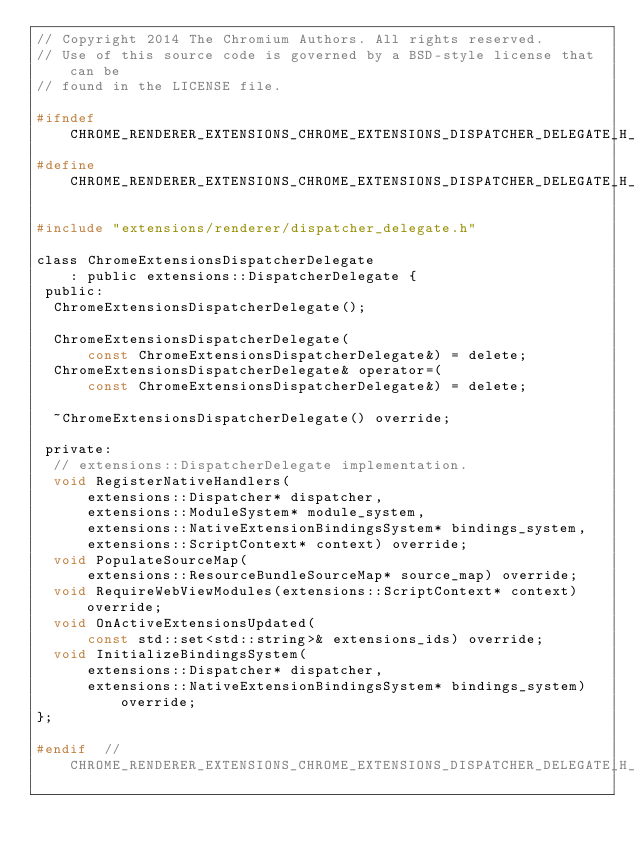Convert code to text. <code><loc_0><loc_0><loc_500><loc_500><_C_>// Copyright 2014 The Chromium Authors. All rights reserved.
// Use of this source code is governed by a BSD-style license that can be
// found in the LICENSE file.

#ifndef CHROME_RENDERER_EXTENSIONS_CHROME_EXTENSIONS_DISPATCHER_DELEGATE_H_
#define CHROME_RENDERER_EXTENSIONS_CHROME_EXTENSIONS_DISPATCHER_DELEGATE_H_

#include "extensions/renderer/dispatcher_delegate.h"

class ChromeExtensionsDispatcherDelegate
    : public extensions::DispatcherDelegate {
 public:
  ChromeExtensionsDispatcherDelegate();

  ChromeExtensionsDispatcherDelegate(
      const ChromeExtensionsDispatcherDelegate&) = delete;
  ChromeExtensionsDispatcherDelegate& operator=(
      const ChromeExtensionsDispatcherDelegate&) = delete;

  ~ChromeExtensionsDispatcherDelegate() override;

 private:
  // extensions::DispatcherDelegate implementation.
  void RegisterNativeHandlers(
      extensions::Dispatcher* dispatcher,
      extensions::ModuleSystem* module_system,
      extensions::NativeExtensionBindingsSystem* bindings_system,
      extensions::ScriptContext* context) override;
  void PopulateSourceMap(
      extensions::ResourceBundleSourceMap* source_map) override;
  void RequireWebViewModules(extensions::ScriptContext* context) override;
  void OnActiveExtensionsUpdated(
      const std::set<std::string>& extensions_ids) override;
  void InitializeBindingsSystem(
      extensions::Dispatcher* dispatcher,
      extensions::NativeExtensionBindingsSystem* bindings_system) override;
};

#endif  // CHROME_RENDERER_EXTENSIONS_CHROME_EXTENSIONS_DISPATCHER_DELEGATE_H_
</code> 